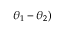<formula> <loc_0><loc_0><loc_500><loc_500>\theta _ { 1 } - \theta _ { 2 } )</formula> 